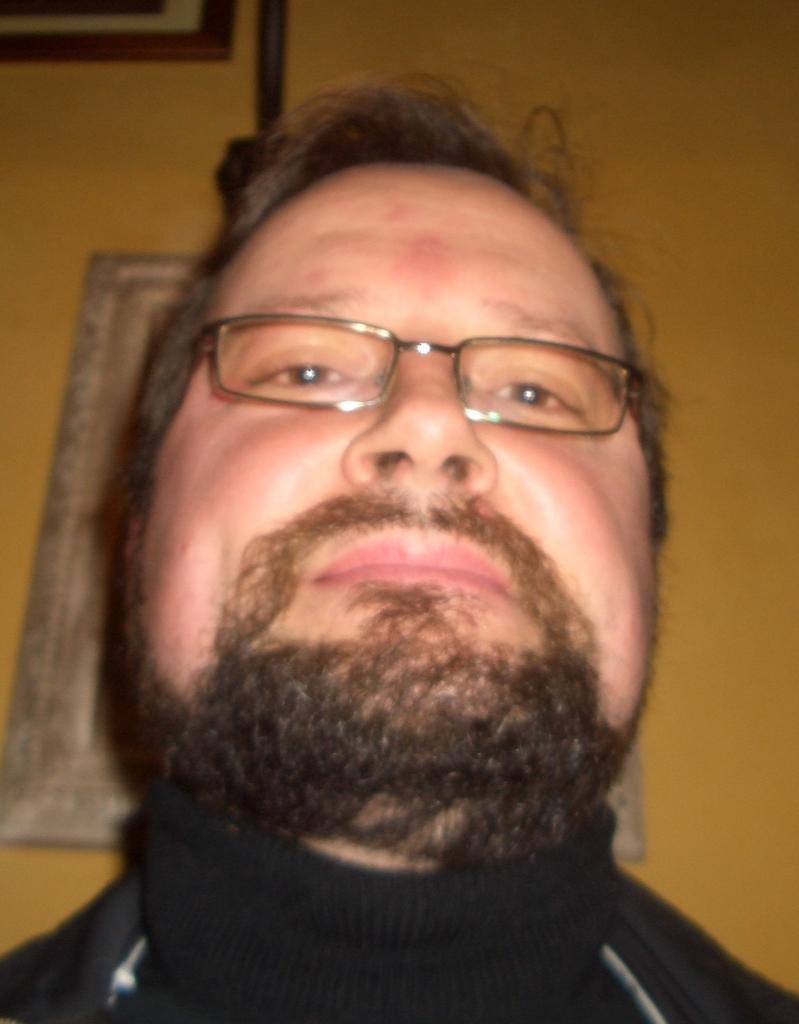Could you give a brief overview of what you see in this image? In the picture we can see a man with a beard and glasses and in the background, we can see a wall which is yellow in color with a photo frame. 